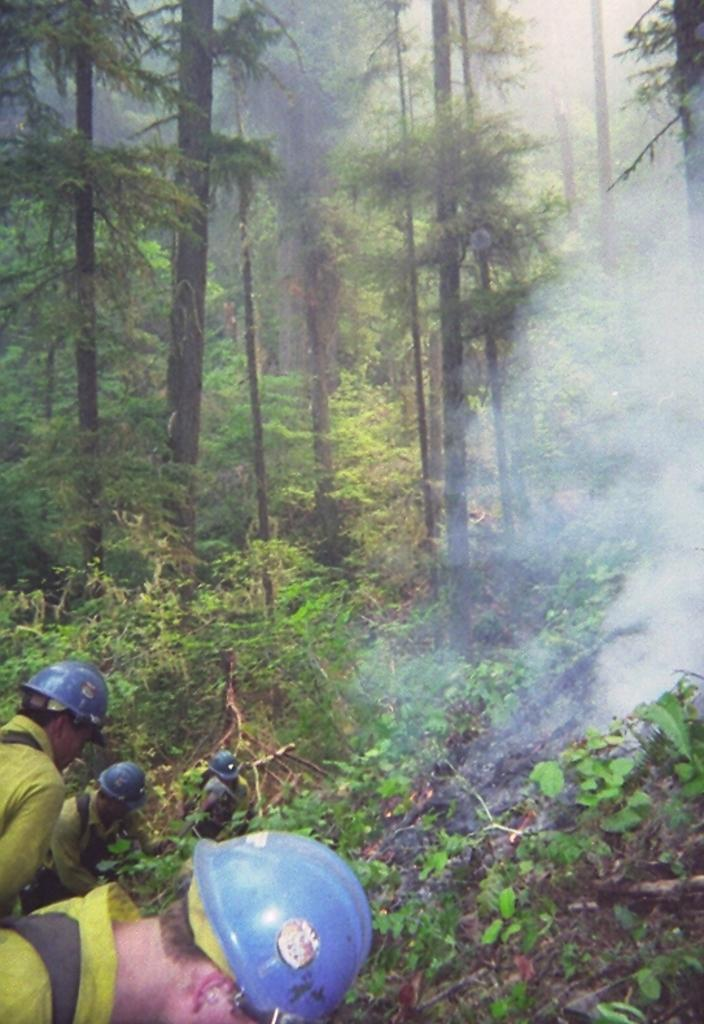Who is present in the image? There are people in the image. What are the people wearing on their heads? The people are wearing helmets. What color clothes are the people wearing? The people are wearing yellow color clothes. What can be seen in the background of the image? There are plants, trees, and smoke visible in the background of the image. What type of behavior can be observed in the people's tails in the image? There are no tails present on the people in the image, so it is not possible to observe any behavior related to tails. 